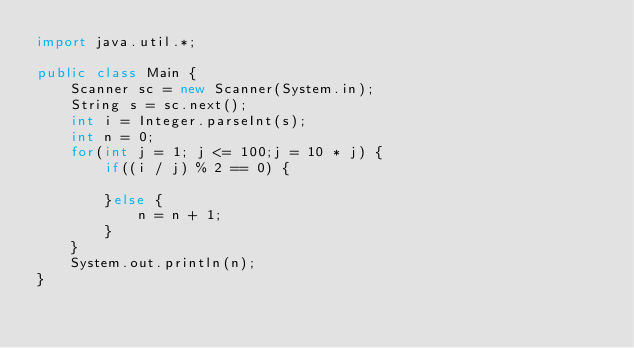<code> <loc_0><loc_0><loc_500><loc_500><_Java_>import java.util.*;

public class Main {
	Scanner sc = new Scanner(System.in);
	String s = sc.next();
	int i = Integer.parseInt(s);
	int n = 0;
	for(int j = 1; j <= 100;j = 10 * j) {
		if((i / j) % 2 == 0) { 
			
		}else {
			n = n + 1;
		}
	}
	System.out.println(n);
}</code> 